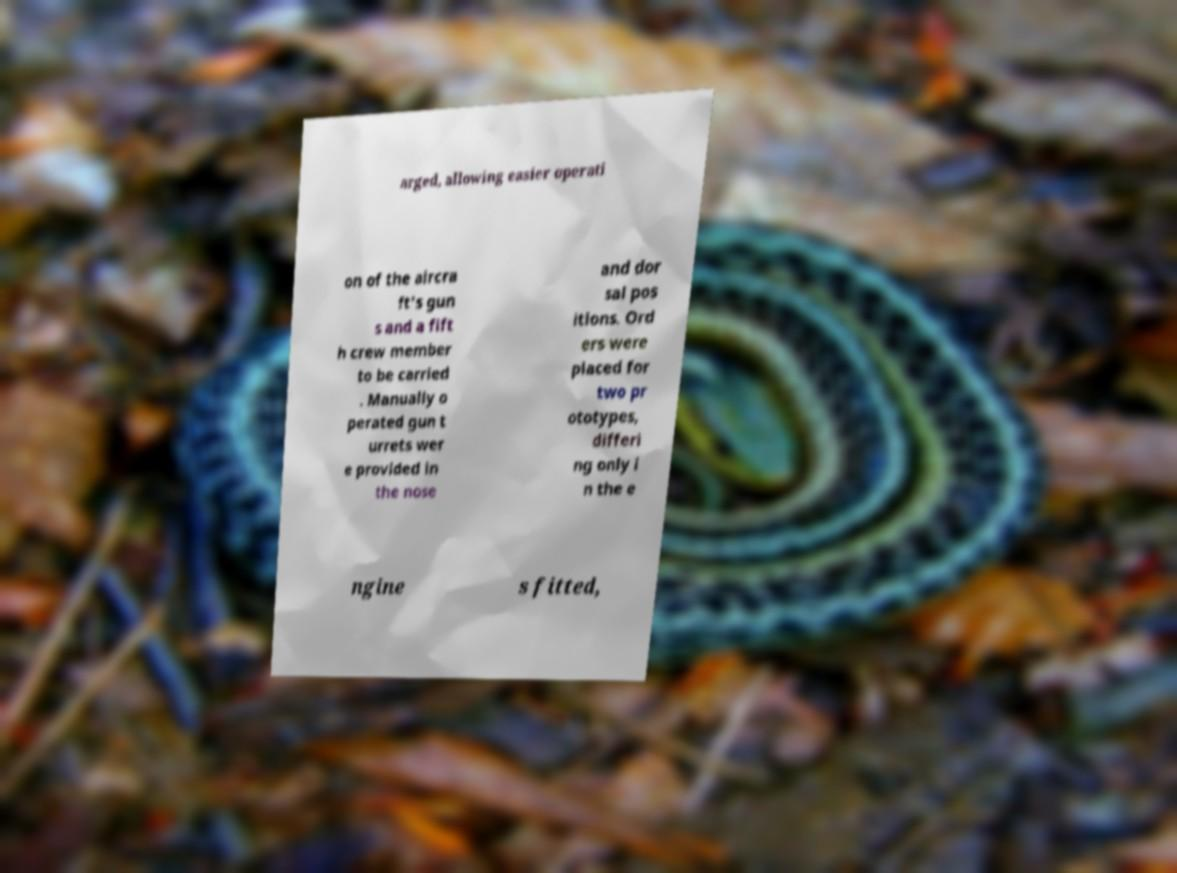What messages or text are displayed in this image? I need them in a readable, typed format. arged, allowing easier operati on of the aircra ft's gun s and a fift h crew member to be carried . Manually o perated gun t urrets wer e provided in the nose and dor sal pos itions. Ord ers were placed for two pr ototypes, differi ng only i n the e ngine s fitted, 